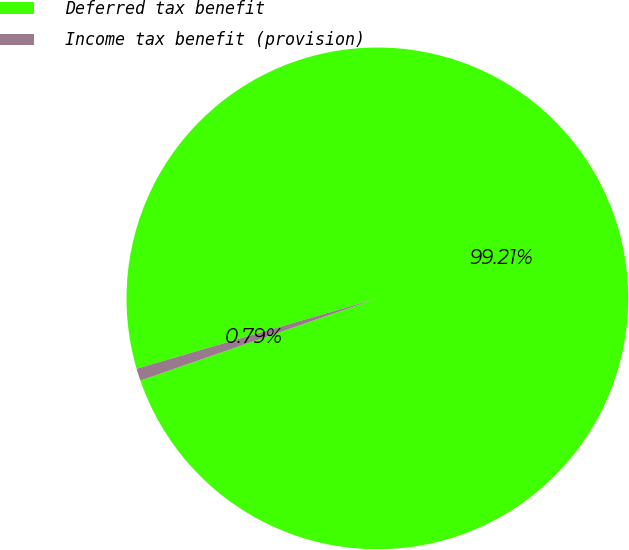Convert chart. <chart><loc_0><loc_0><loc_500><loc_500><pie_chart><fcel>Deferred tax benefit<fcel>Income tax benefit (provision)<nl><fcel>99.21%<fcel>0.79%<nl></chart> 